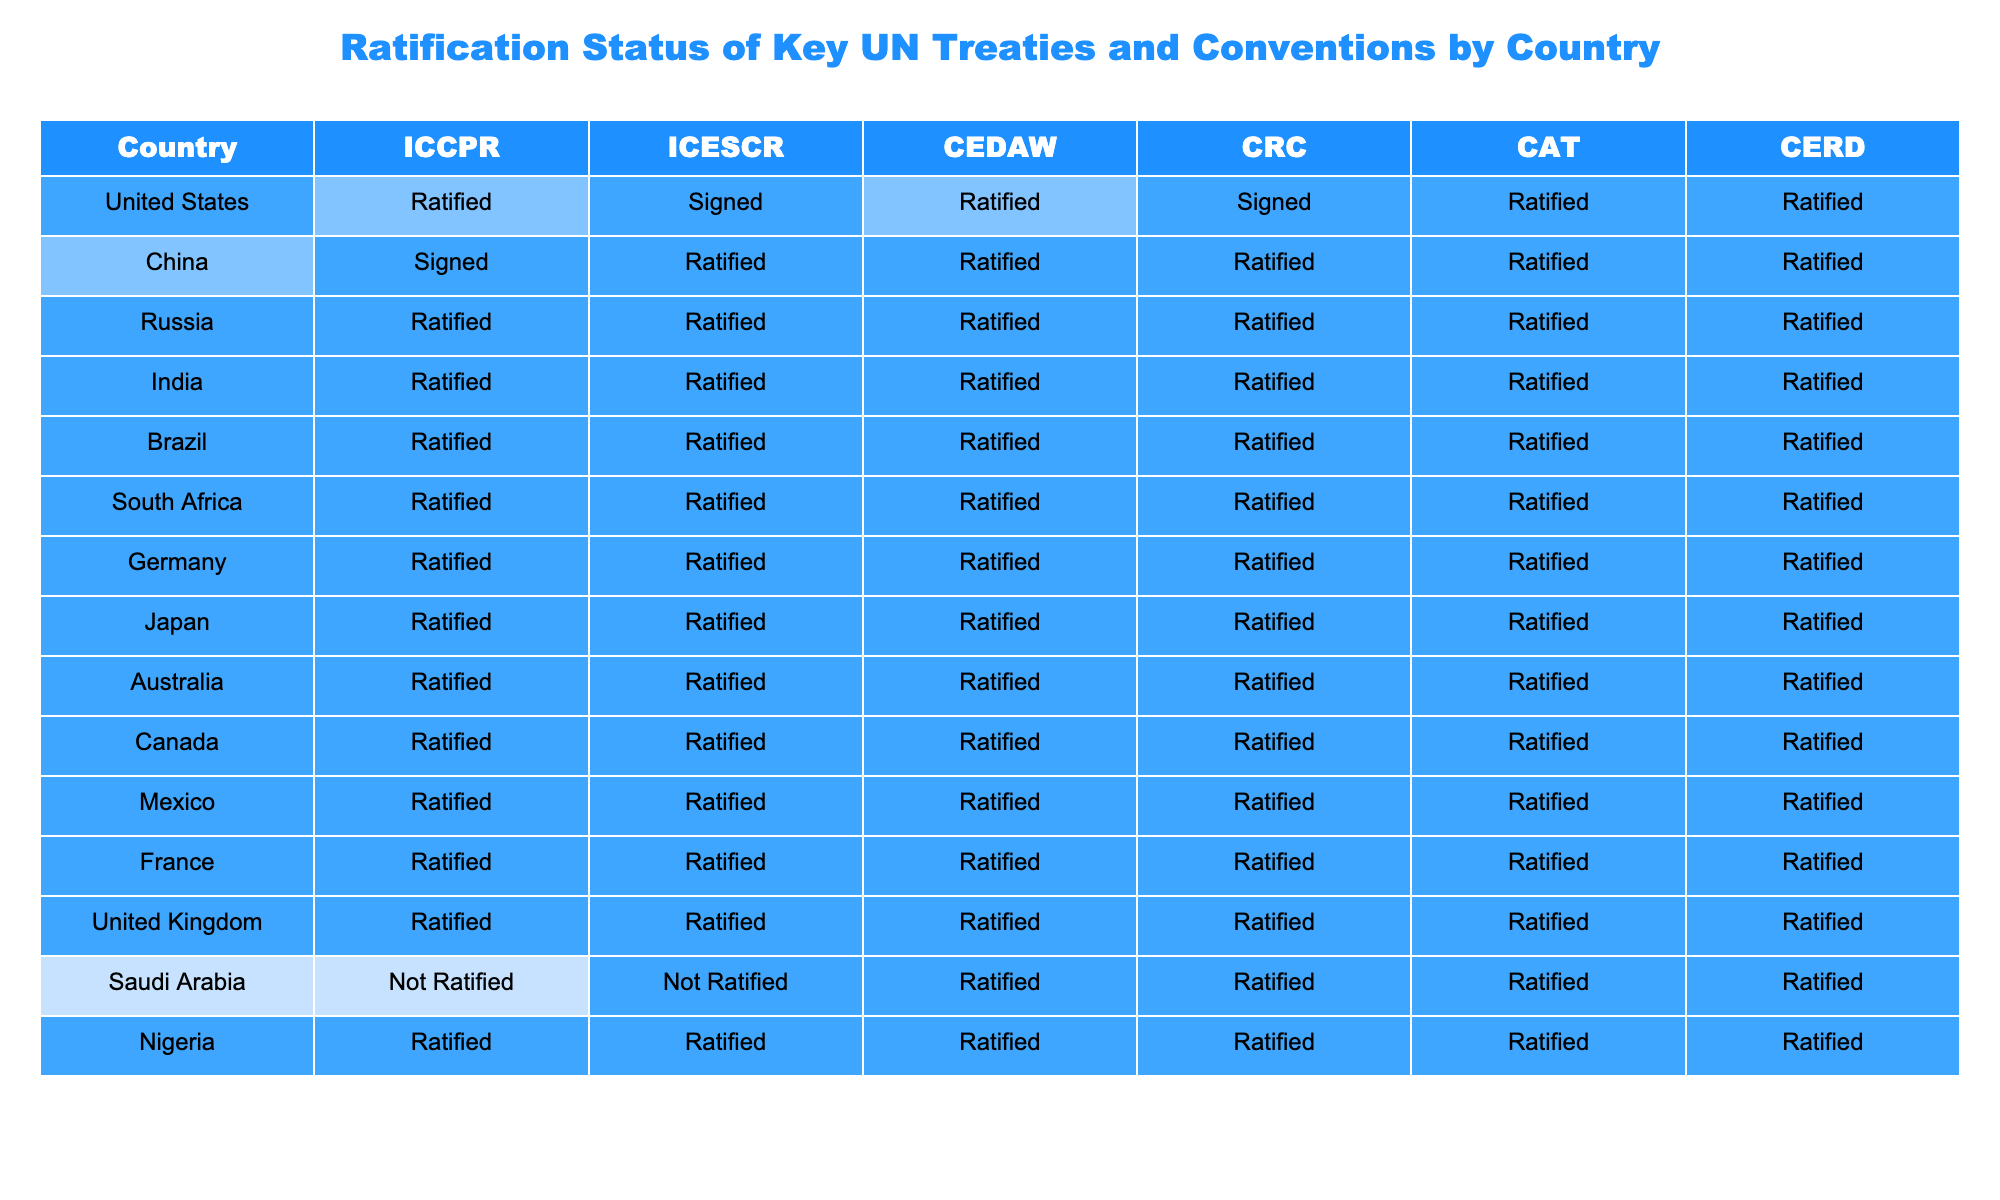What is the ratification status of the ICCPR by China? The table shows that China has signed the ICCPR but has not ratified it.
Answer: Signed How many countries have ratified the CEDAW? By counting the 'Ratified' statuses for CEDAW in the table, we find that there are 10 countries that have ratified it.
Answer: 10 Has Saudi Arabia ratified the ICESCR? The table indicates that Saudi Arabia has not ratified the ICESCR, as it is marked as 'Not Ratified'.
Answer: No Which country has ratified all listed treaties and conventions? Reviewing the table, Russia, India, Brazil, South Africa, Germany, Japan, Australia, Canada, Mexico, France, and the United Kingdom are the countries that have ratified all treaties.
Answer: 12 countries Which treaty has the highest number of 'Not Ratified' statuses? By analyzing the columns, we see that the ICESCR has the highest number of 'Not Ratified' statuses, with Saudi Arabia being the only listed country.
Answer: ICESCR Is there any country that has only signed the ICCPR? Upon looking at the table, the United States has only signed the ICCPR but not ratified it, making it the only instance of this status in the data presented.
Answer: Yes How many treaties has the United States ratified compared to China? The table shows that the United States has ratified 4 treaties whereas China has ratified 5 treaties. This indicates China has ratified one more treaty than the United States.
Answer: China has ratified 1 more treaty Are there any countries that have ratified the CRC but not the CAT? Checking the statuses for the CRC and CAT shows that Saudi Arabia has ratified the CRC while it did not ratify the CAT.
Answer: Yes How many countries in total have not ratified any treaties? In the entire table, only Saudi Arabia has a status of 'Not Ratified' for any of the treaties, indicating it has not ratified any treaties included in this data.
Answer: 1 country What is the total number of countries that have ratified the CRC? The table lists 12 countries that have ratified the CRC, as only Saudi Arabia has not ratified it while all others have.
Answer: 12 